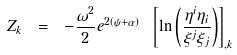Convert formula to latex. <formula><loc_0><loc_0><loc_500><loc_500>Z _ { k } \ = \ - \frac { \omega ^ { 2 } } { 2 } e ^ { 2 ( \psi + \alpha ) } \ \left [ \ln \left ( \frac { \eta ^ { i } \eta _ { i } } { \xi ^ { j } \xi _ { j } } \right ) \right ] _ { , k }</formula> 